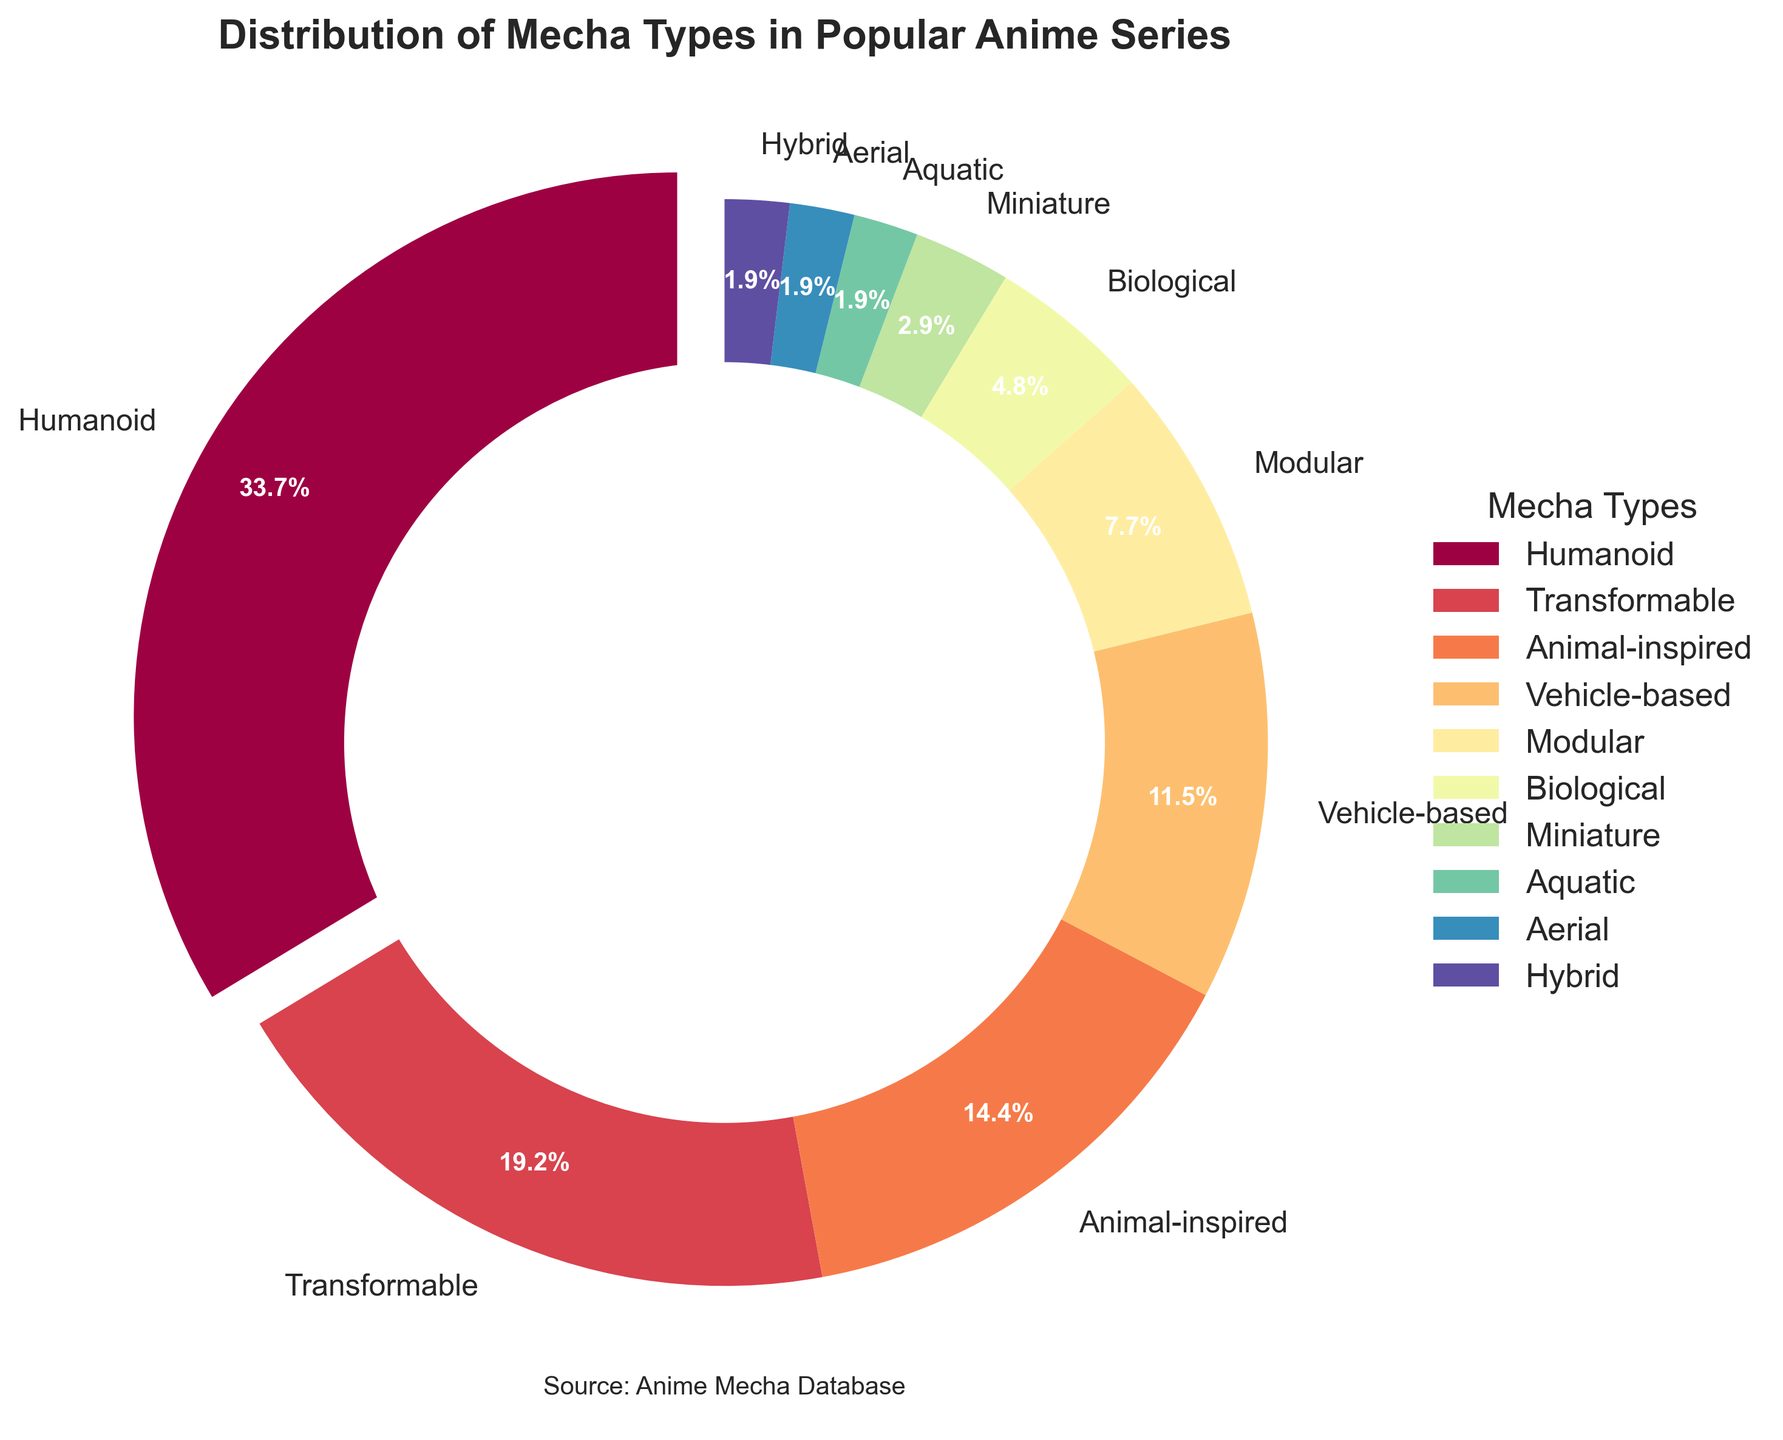What's the most common type of mecha? The pie chart shows the distribution of mecha types and highlights that 'Humanoid' mecha have the largest segment at 35%. This is also highlighted by the slight 'explode' effect for visual emphasis.
Answer: Humanoid How much larger is the percentage of Humanoid mecha than the second most common type? The percentage of Humanoid mecha is 35%, while the second most common type, Transformable mecha, has a 20% share. The difference is calculated as 35% - 20% = 15%.
Answer: 15% What is the combined percentage of Animal-inspired and Vehicle-based mechas? According to the figure, Animal-inspired mechas account for 15% and Vehicle-based mechas account for 12%. Their combined percentage is 15% + 12% = 27%.
Answer: 27% Which mecha type forms the smallest slice of the pie chart? The pie chart shows that several mecha types have very small percentages of 2% each, namely Aquatic, Aerial, and Hybrid. Consequently, these types represent the smallest slices in the chart.
Answer: Aquatic, Aerial, and Hybrid Which mecha types each have less than 10% representation? From the chart, mecha types with less than 10% representation are: Modular (8%), Biological (5%), Miniature (3%), Aquatic (2%), Aerial (2%), and Hybrid (2%).
Answer: Modular, Biological, Miniature, Aquatic, Aerial, Hybrid What percentage of the chart is composed of Modular, Biological, and Miniature mechas combined? The percentages for Modular, Biological, and Miniature mechas are 8%, 5%, and 3% respectively. Their combined total is 8% + 5% + 3% = 16%.
Answer: 16% Is the proportion of Transformable mechas greater or smaller than the combined proportion of Modular and Biological mechas? Transformable mechas make up 20% of the distribution. Modular mechas account for 8% and Biological mechas 5%, summing to 8% + 5% = 13%. Consequently, 20% is greater than 13%.
Answer: Greater What is the percentage of mecha types that fall under 5% representation? Mecha types with less than 5% representation are Miniature (3%), Aquatic (2%), Aerial (2%), and Hybrid (2%). Summing their percentages, we get 3% + 2% + 2% + 2% = 9%.
Answer: 9% What is the visual color gradient pattern used in the pie chart and how does it aid in distinguishing mecha types? The pie chart uses a gradient color scheme from the Spectral colormap. This provides a spectrum of different colors for each segment, aiding in visually distinguishing between different mecha types effectively.
Answer: Gradient color scheme What fraction of the pie chart is dedicated to Humanoid and Transformable mechas together? Humanoid mechas constitute 35% and Transformable mechas make up 20%. Together, they represent 35% + 20% = 55% of the pie chart. In fraction form, this is 55/100 or 11/20.
Answer: 11/20 